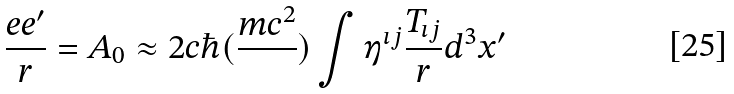Convert formula to latex. <formula><loc_0><loc_0><loc_500><loc_500>\frac { e e ^ { \prime } } { r } = A _ { 0 } \approx 2 c \hbar { ( } \frac { m c ^ { 2 } } { } ) \int \eta ^ { \imath j } \frac { T _ { \imath j } } { r } d ^ { 3 } x ^ { \prime }</formula> 